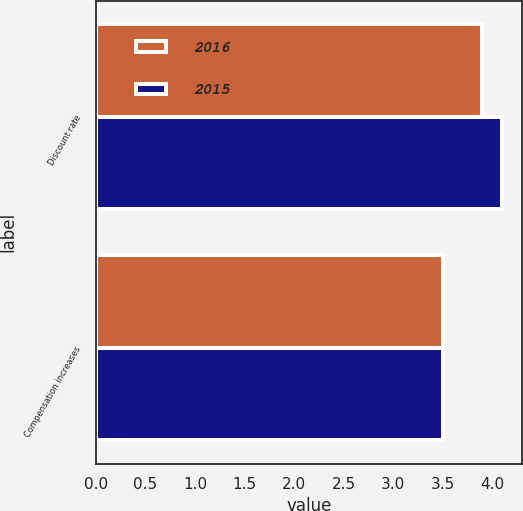<chart> <loc_0><loc_0><loc_500><loc_500><stacked_bar_chart><ecel><fcel>Discount rate<fcel>Compensation increases<nl><fcel>2016<fcel>3.9<fcel>3.5<nl><fcel>2015<fcel>4.1<fcel>3.5<nl></chart> 